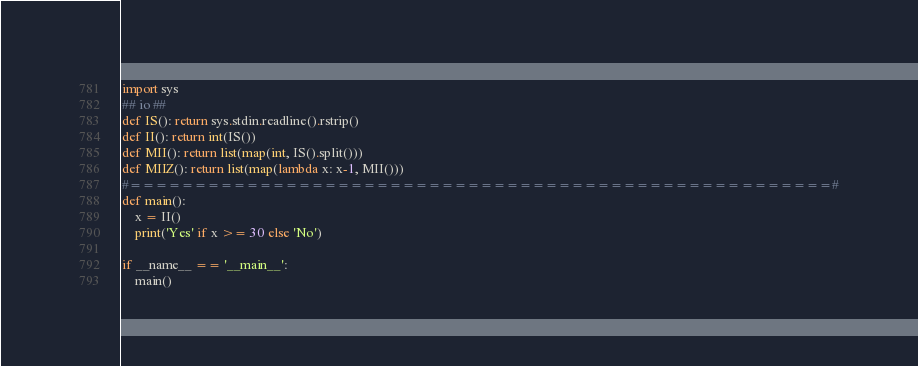Convert code to text. <code><loc_0><loc_0><loc_500><loc_500><_Python_>import sys
## io ##
def IS(): return sys.stdin.readline().rstrip()
def II(): return int(IS())
def MII(): return list(map(int, IS().split()))
def MIIZ(): return list(map(lambda x: x-1, MII()))
#======================================================#
def main():
    x = II()
    print('Yes' if x >= 30 else 'No')

if __name__ == '__main__':
    main()</code> 